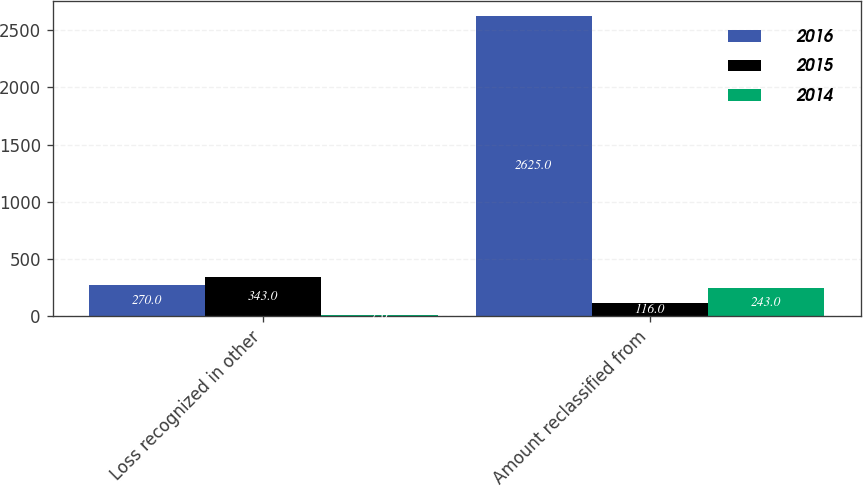<chart> <loc_0><loc_0><loc_500><loc_500><stacked_bar_chart><ecel><fcel>Loss recognized in other<fcel>Amount reclassified from<nl><fcel>2016<fcel>270<fcel>2625<nl><fcel>2015<fcel>343<fcel>116<nl><fcel>2014<fcel>7<fcel>243<nl></chart> 